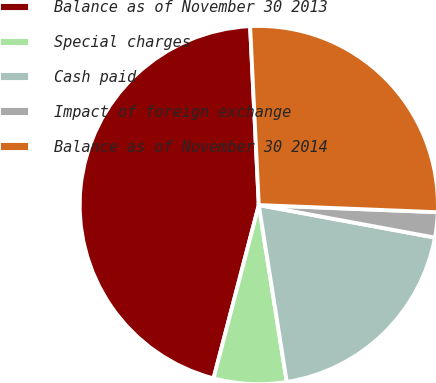Convert chart to OTSL. <chart><loc_0><loc_0><loc_500><loc_500><pie_chart><fcel>Balance as of November 30 2013<fcel>Special charges<fcel>Cash paid<fcel>Impact of foreign exchange<fcel>Balance as of November 30 2014<nl><fcel>45.16%<fcel>6.56%<fcel>19.6%<fcel>2.27%<fcel>26.41%<nl></chart> 